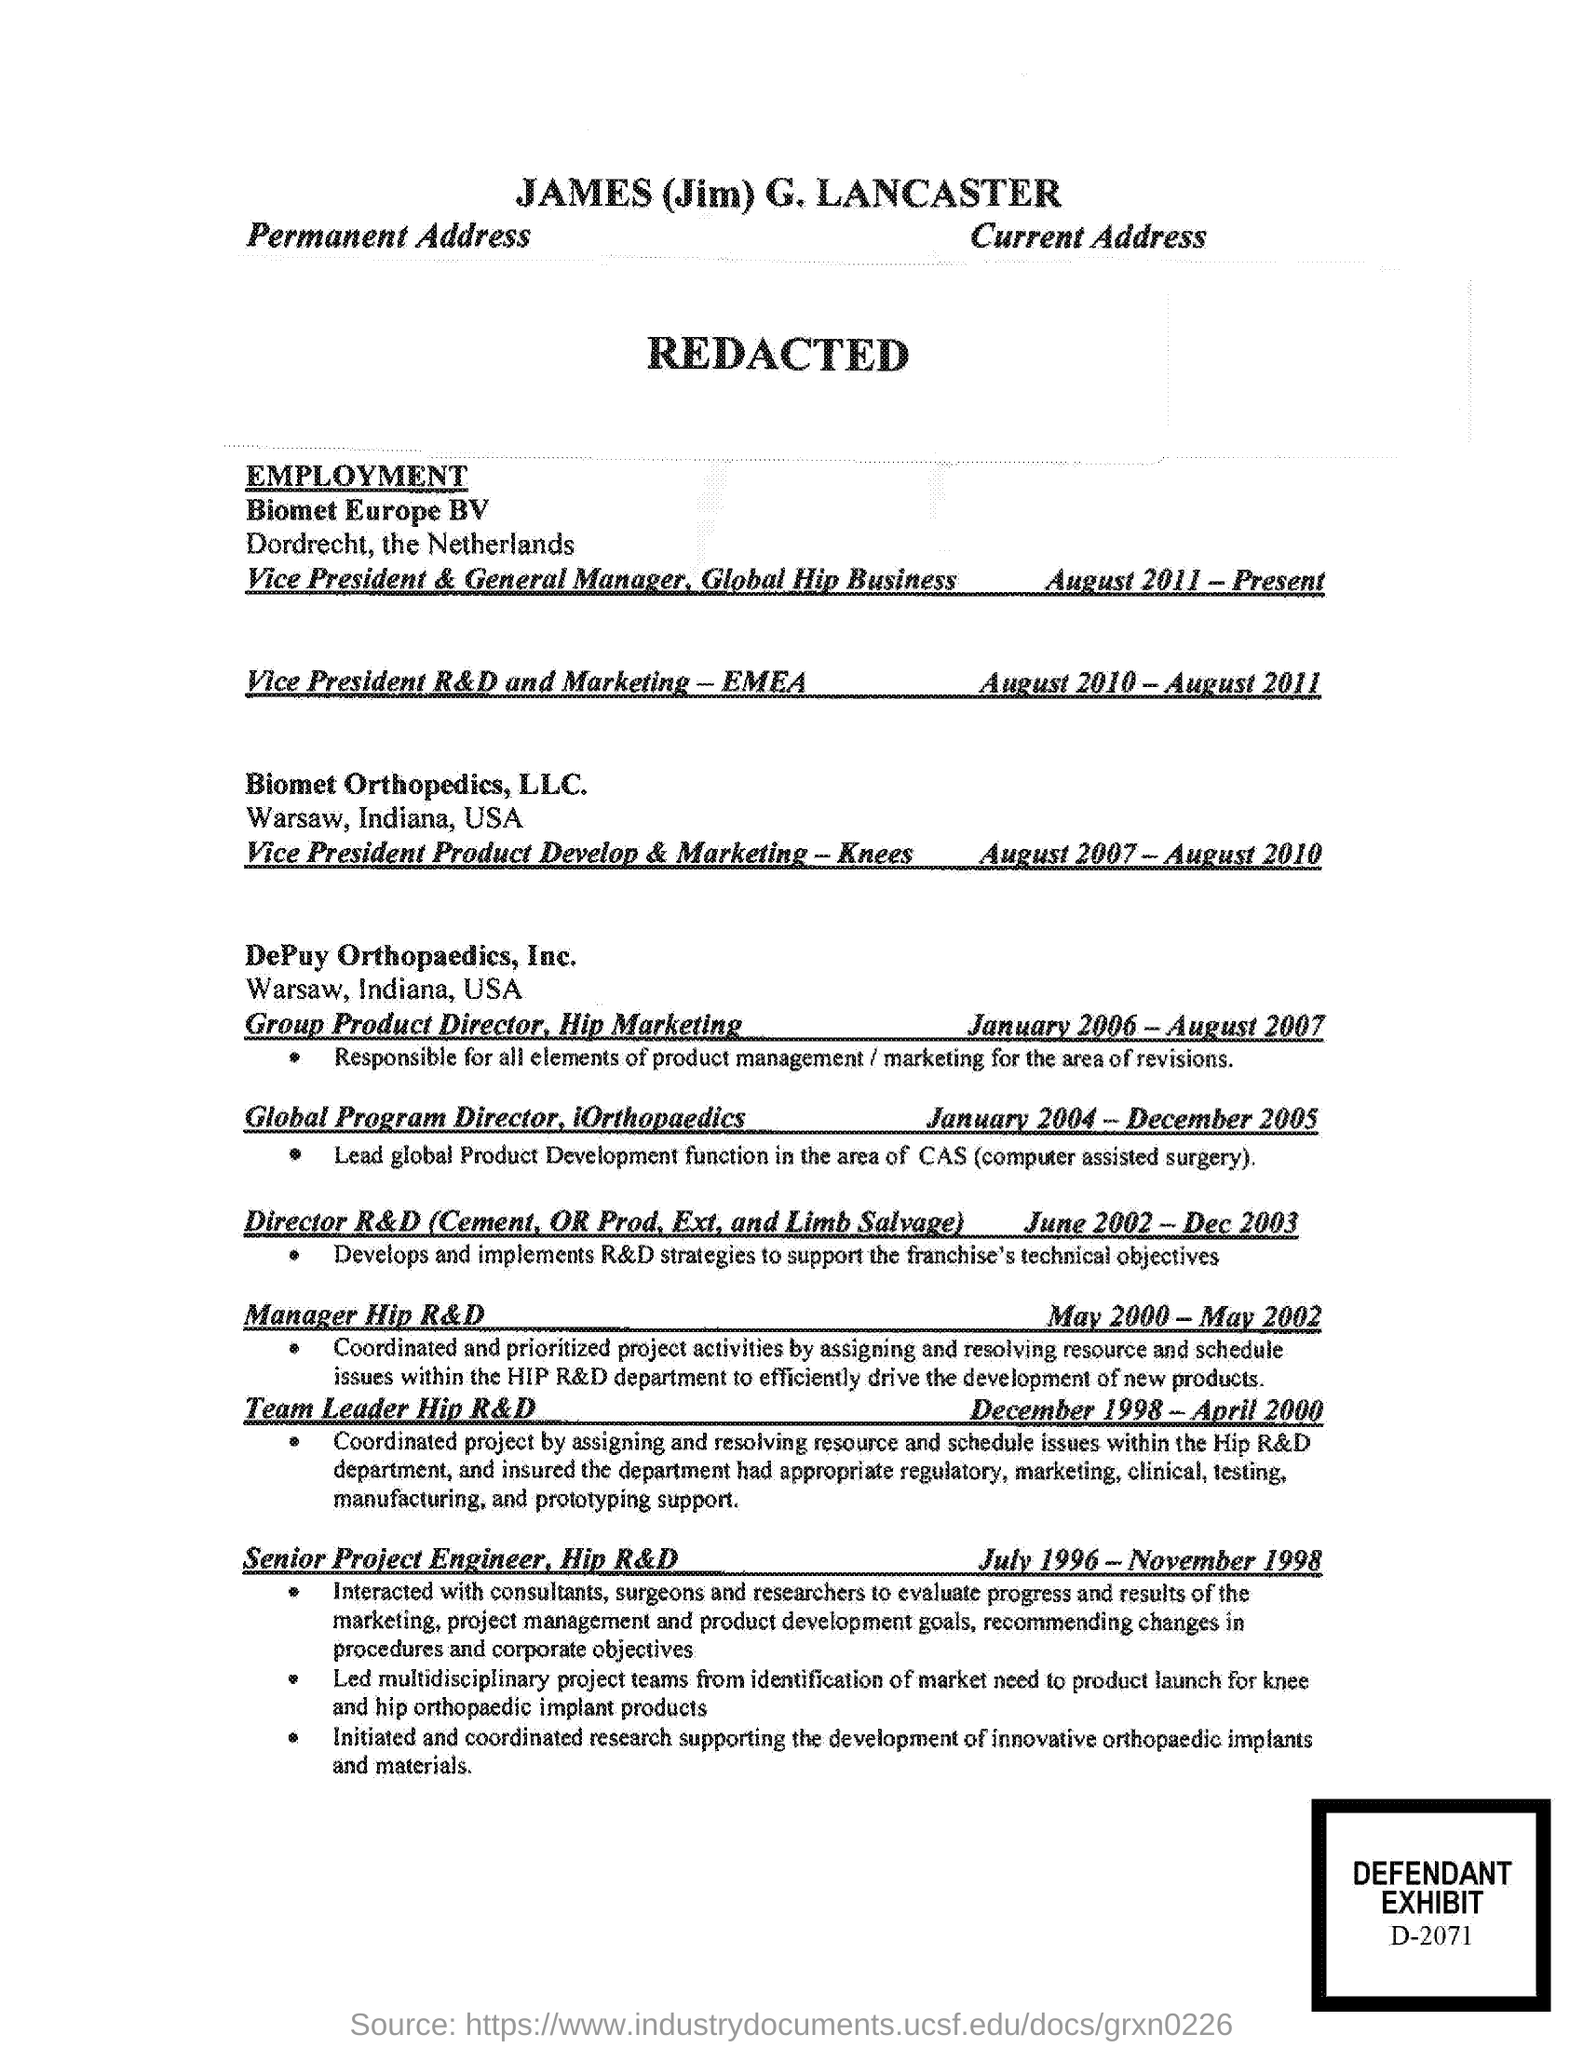Give some essential details in this illustration. The defendant exhibit number is D-2071... 